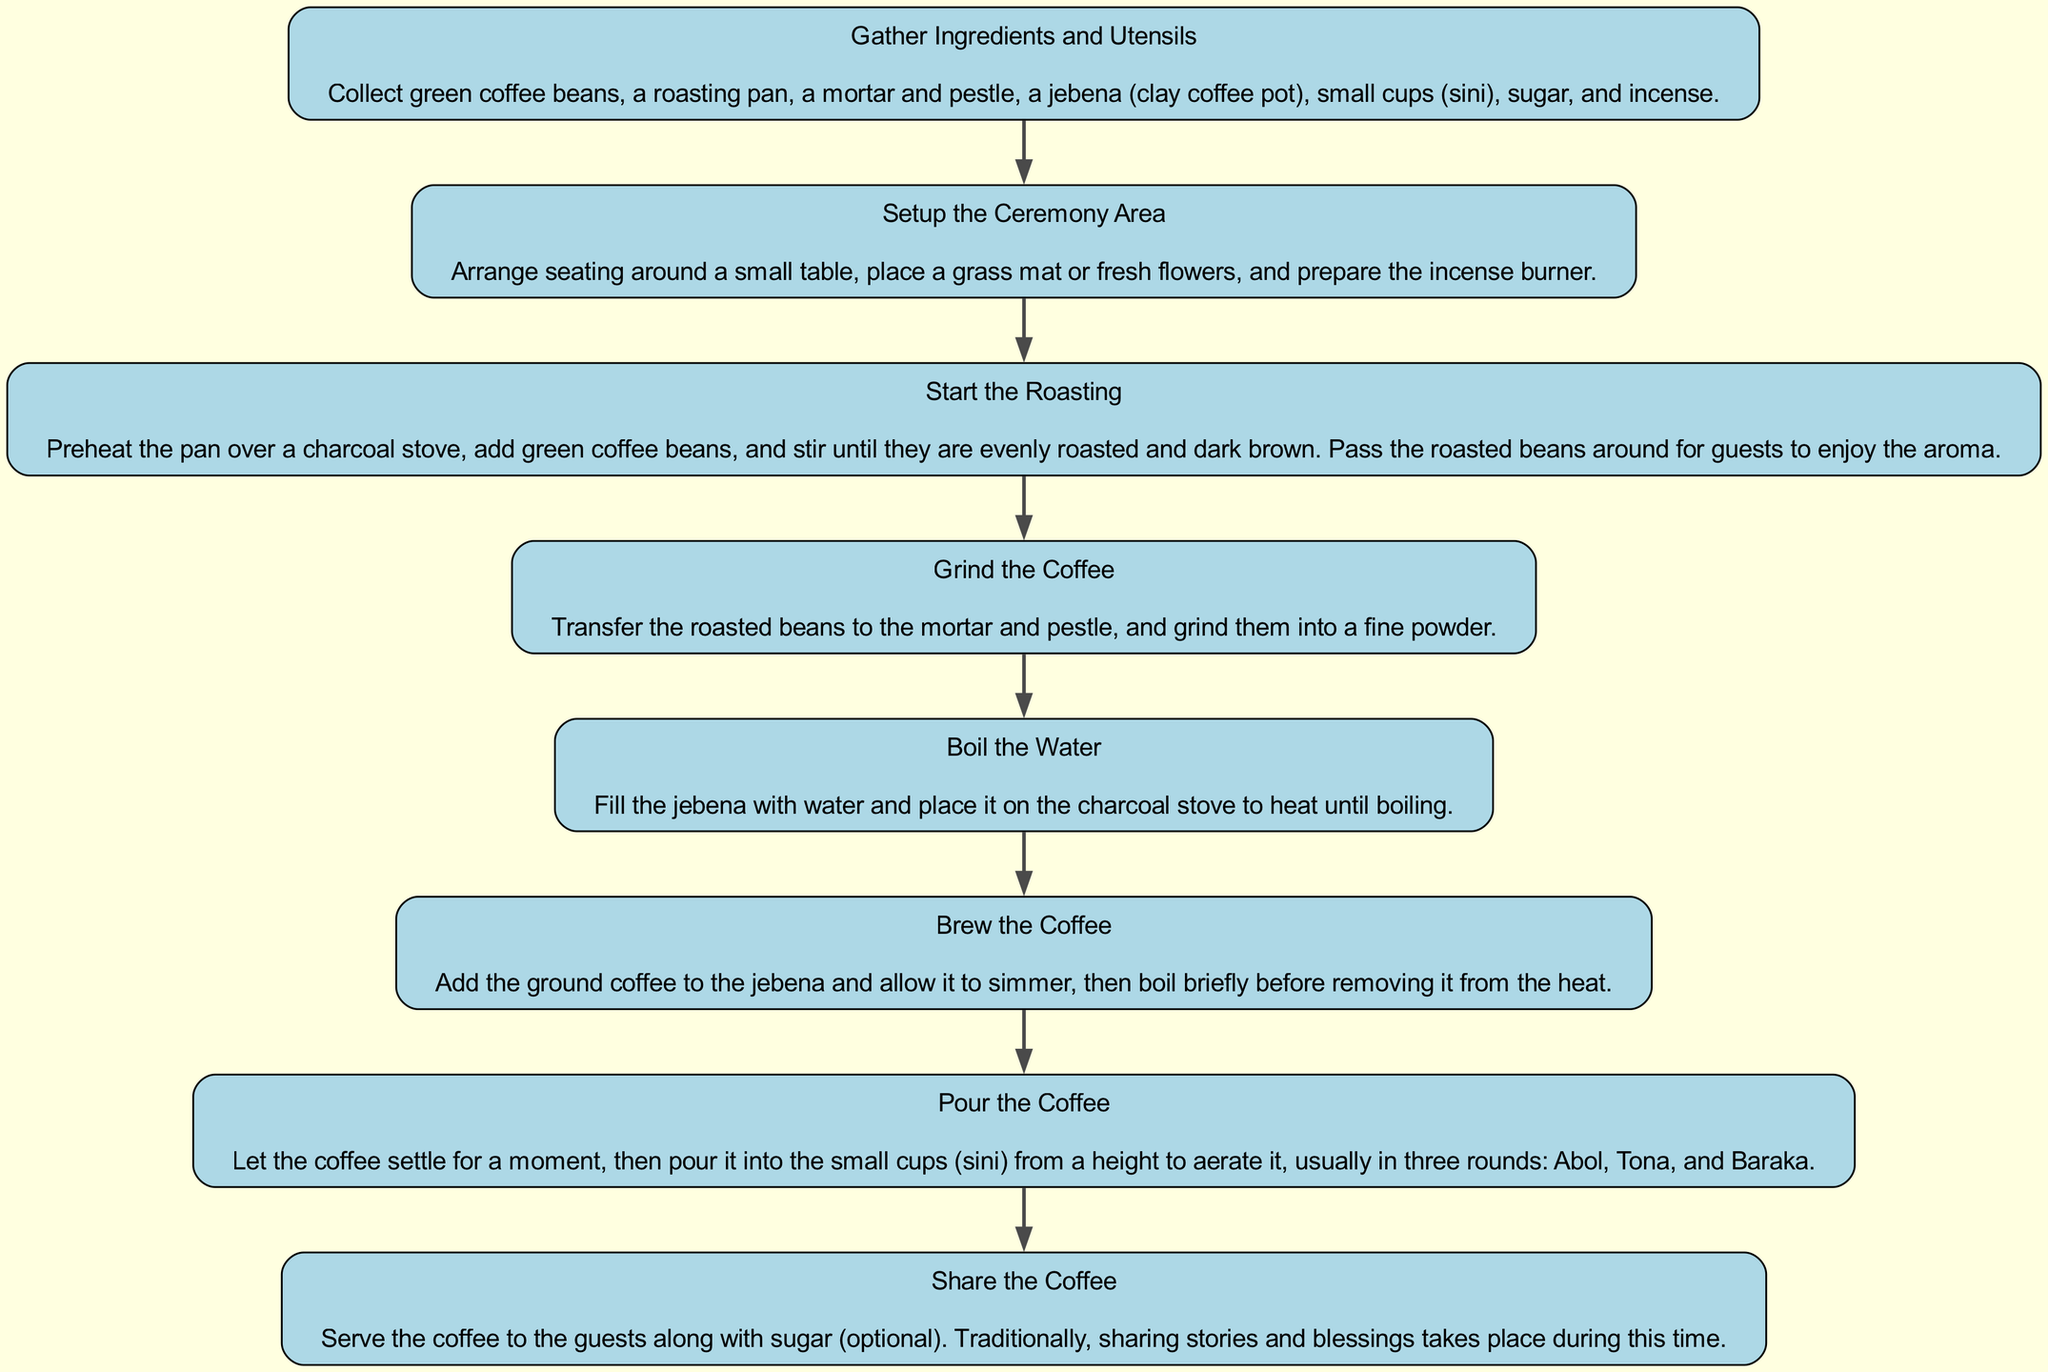What is the first step in the Ethiopian coffee ceremony? The first step is represented by the first node in the diagram which is "Gather Ingredients and Utensils." This is confirmed by the flow starting from the top of the diagram.
Answer: Gather Ingredients and Utensils How many total steps are there in the Ethiopian coffee ceremony? By counting the nodes in the diagram, there are eight distinct steps listed before sharing the coffee.
Answer: Eight What is the last step in the process? The last step is indicated in the diagram as "Share the Coffee," which is located at the bottom of the flow.
Answer: Share the Coffee What do you do after grinding the coffee? Following the "Grind the Coffee" step, the next node that indicates what to do is "Boil the Water." This shows the sequential order of steps in the process.
Answer: Boil the Water What is served along with the coffee during sharing? The description in the final node confirms that sugar is served optionally with the coffee during the sharing part of the ceremony.
Answer: Sugar Which step involves preheating a pan? The third step in the diagram clearly states "Start the Roasting," which includes the action of preheating the pan over a charcoal stove.
Answer: Start the Roasting How many rounds are involved in pouring the coffee? The pour step mentions three rounds, identified as "Abol," "Tona," and "Baraka," which are outlined in the description of the "Pour the Coffee" step.
Answer: Three rounds What utensil is used for boiling water? According to the diagram, the water is boiled in a "jebena," as specified in the description of the "Boil the Water" step.
Answer: Jebena 